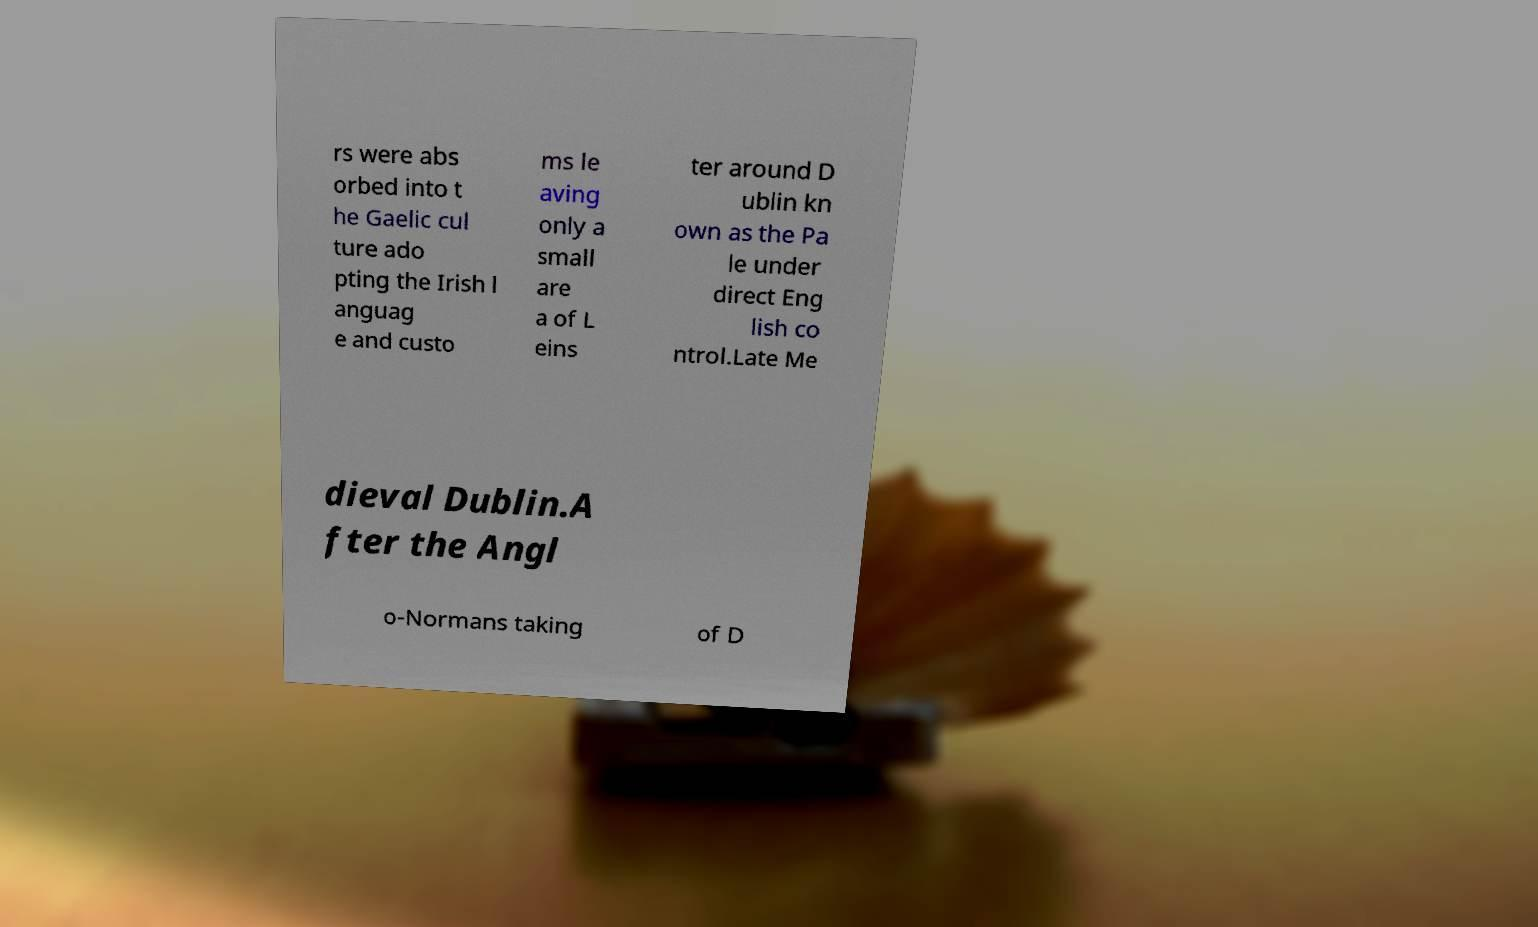I need the written content from this picture converted into text. Can you do that? rs were abs orbed into t he Gaelic cul ture ado pting the Irish l anguag e and custo ms le aving only a small are a of L eins ter around D ublin kn own as the Pa le under direct Eng lish co ntrol.Late Me dieval Dublin.A fter the Angl o-Normans taking of D 